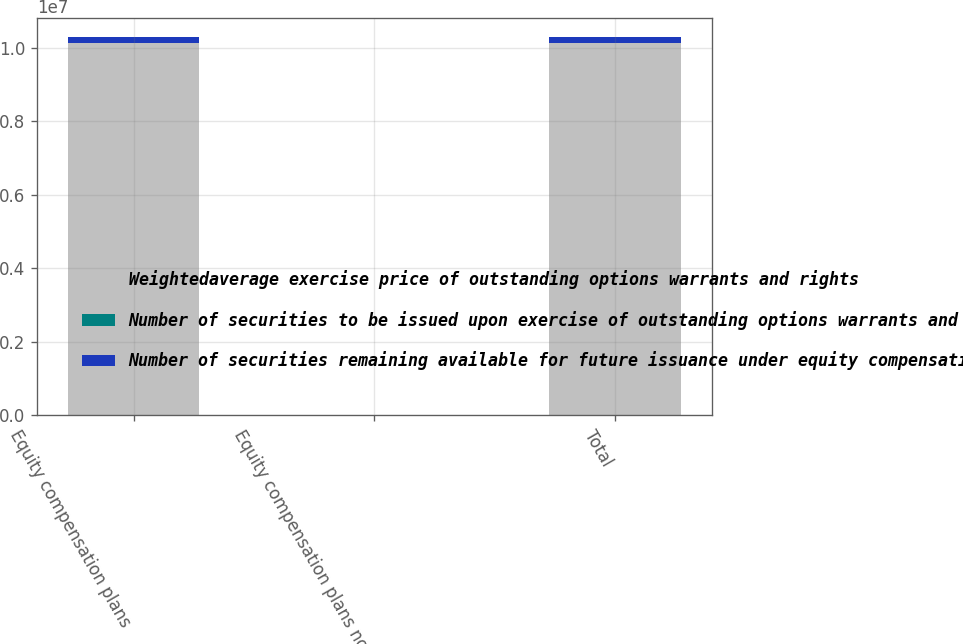<chart> <loc_0><loc_0><loc_500><loc_500><stacked_bar_chart><ecel><fcel>Equity compensation plans<fcel>Equity compensation plans not<fcel>Total<nl><fcel>Weightedaverage exercise price of outstanding options warrants and rights<fcel>1.01238e+07<fcel>0<fcel>1.01238e+07<nl><fcel>Number of securities to be issued upon exercise of outstanding options warrants and rights<fcel>51.14<fcel>0<fcel>51.14<nl><fcel>Number of securities remaining available for future issuance under equity compensation plans<fcel>170176<fcel>0<fcel>170176<nl></chart> 